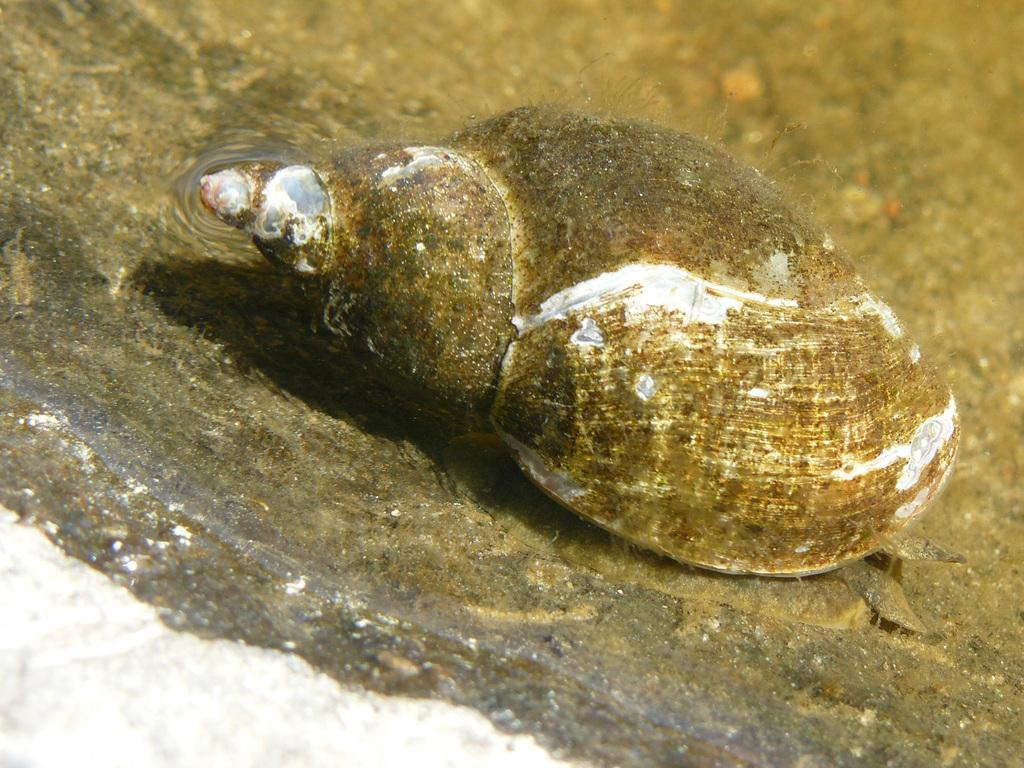What is the main object in the image? There is a seashell in the image. Where is the seashell located? The seashell is on a surface. Is the person swimming in the image? There is no person or swimming activity depicted in the image. 